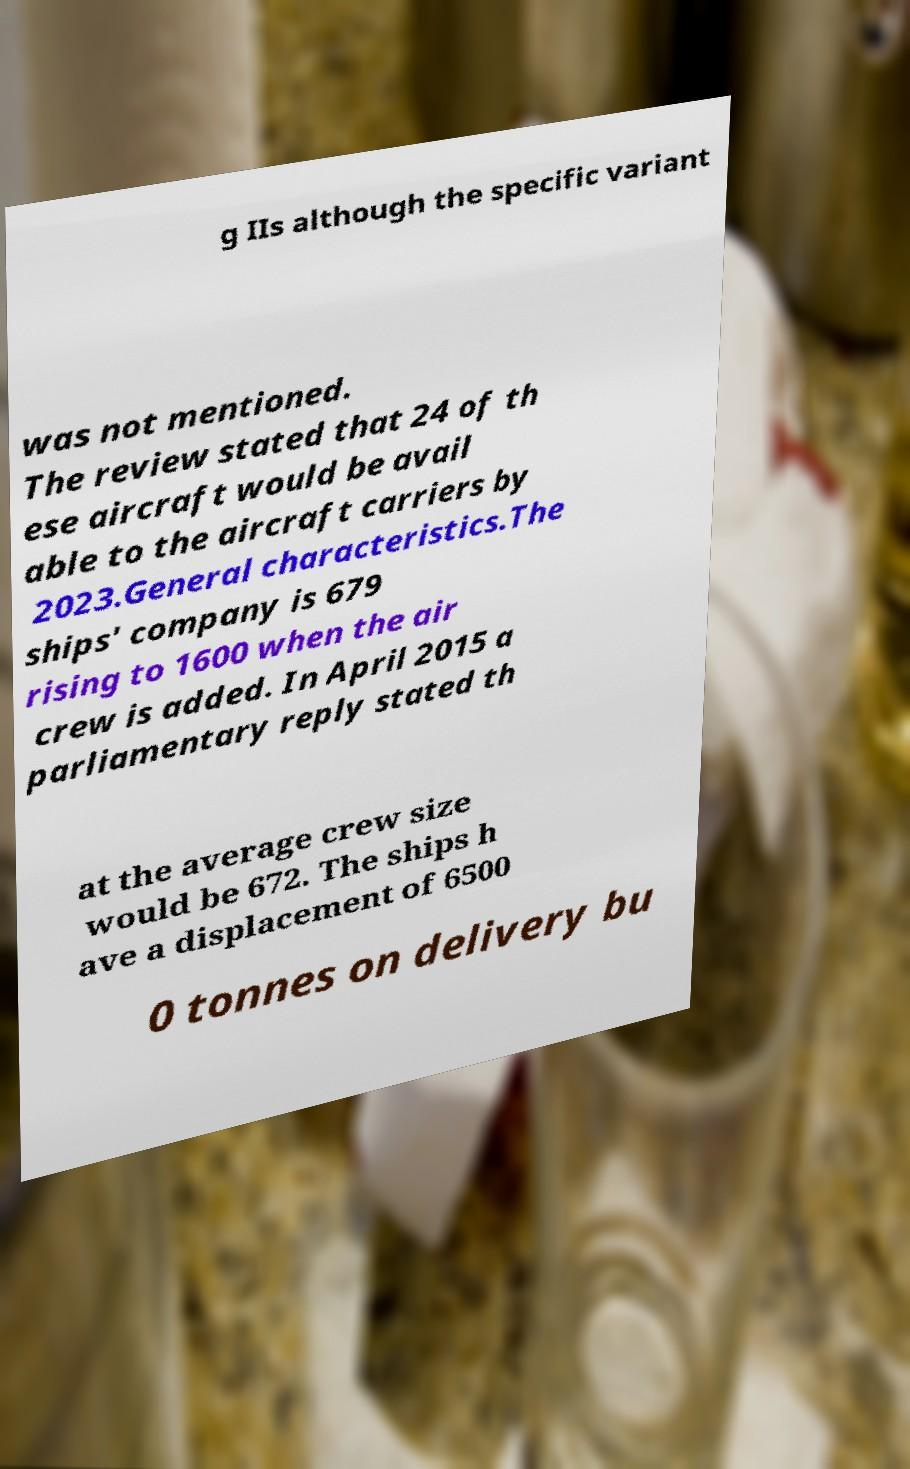Could you assist in decoding the text presented in this image and type it out clearly? g IIs although the specific variant was not mentioned. The review stated that 24 of th ese aircraft would be avail able to the aircraft carriers by 2023.General characteristics.The ships' company is 679 rising to 1600 when the air crew is added. In April 2015 a parliamentary reply stated th at the average crew size would be 672. The ships h ave a displacement of 6500 0 tonnes on delivery bu 